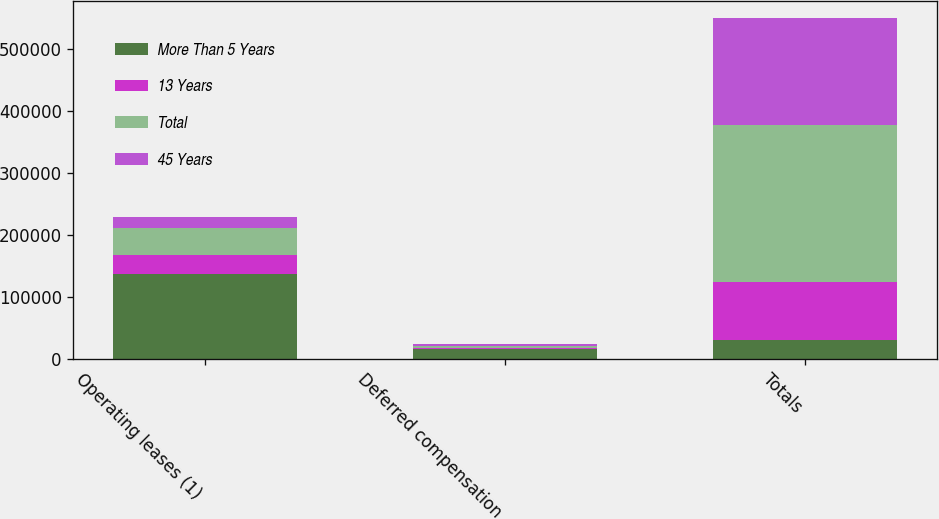Convert chart to OTSL. <chart><loc_0><loc_0><loc_500><loc_500><stacked_bar_chart><ecel><fcel>Operating leases (1)<fcel>Deferred compensation<fcel>Totals<nl><fcel>More Than 5 Years<fcel>136484<fcel>16537<fcel>30980<nl><fcel>13 Years<fcel>30980<fcel>1469<fcel>92505<nl><fcel>Total<fcel>43448<fcel>3164<fcel>254362<nl><fcel>45 Years<fcel>18628<fcel>2766<fcel>172144<nl></chart> 